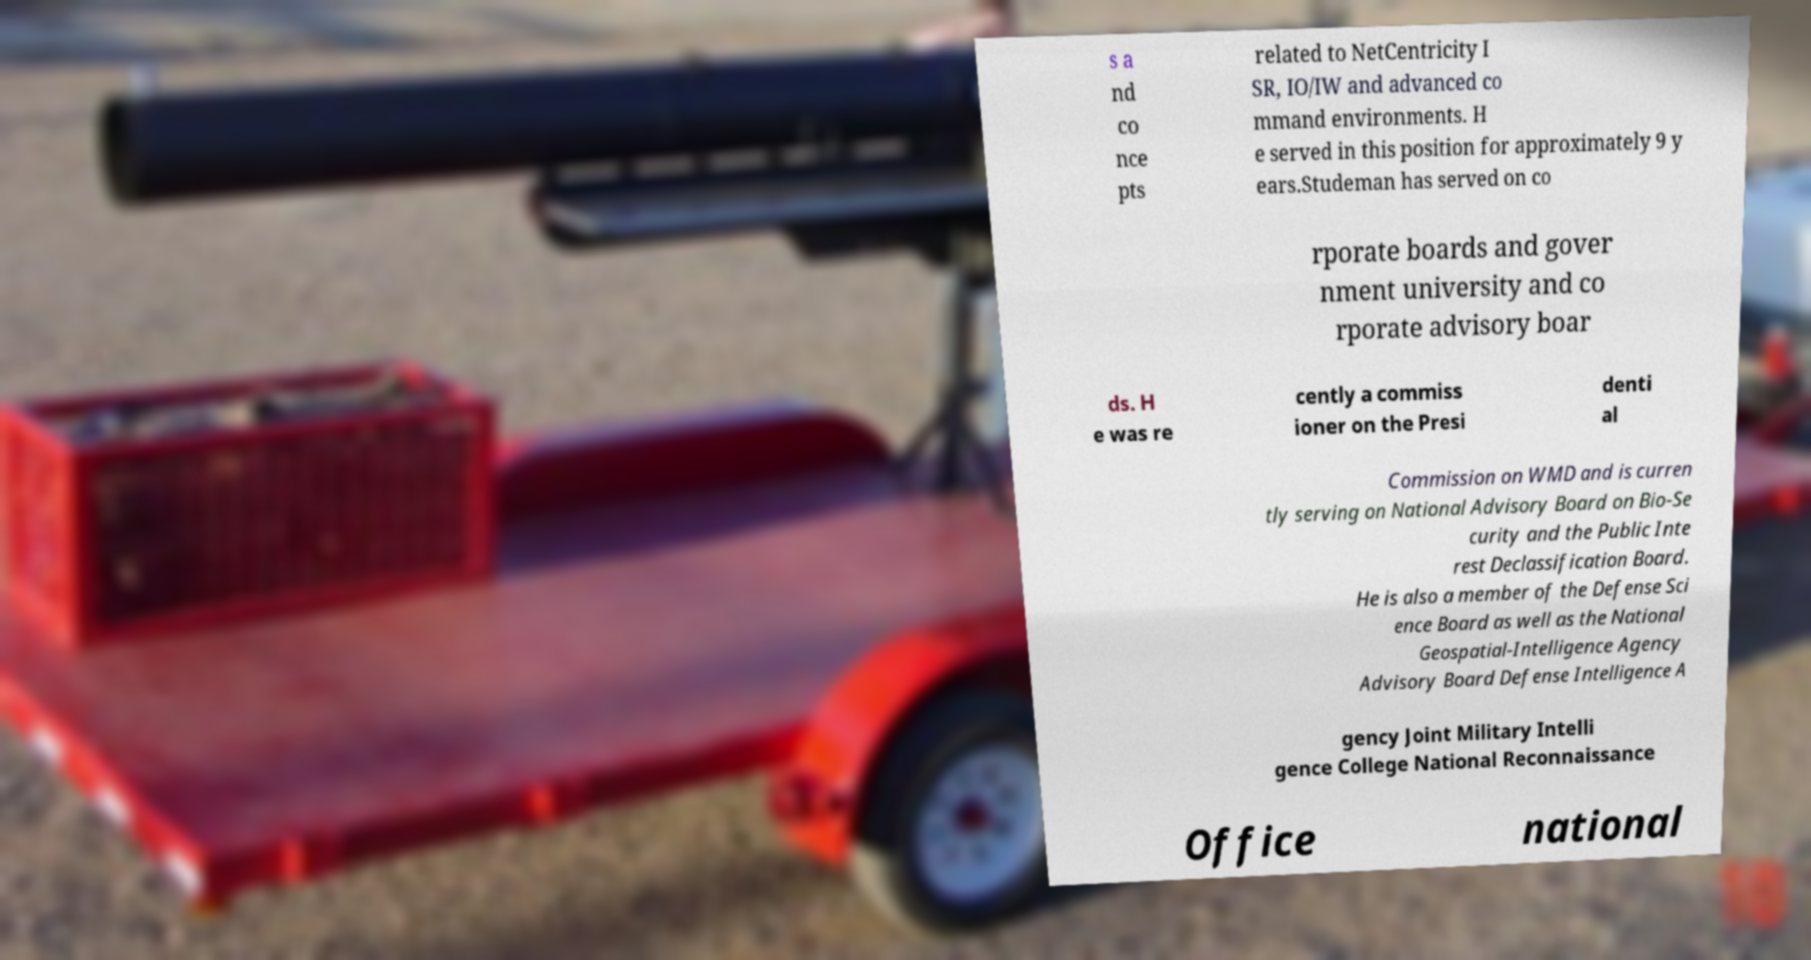There's text embedded in this image that I need extracted. Can you transcribe it verbatim? s a nd co nce pts related to NetCentricity I SR, IO/IW and advanced co mmand environments. H e served in this position for approximately 9 y ears.Studeman has served on co rporate boards and gover nment university and co rporate advisory boar ds. H e was re cently a commiss ioner on the Presi denti al Commission on WMD and is curren tly serving on National Advisory Board on Bio-Se curity and the Public Inte rest Declassification Board. He is also a member of the Defense Sci ence Board as well as the National Geospatial-Intelligence Agency Advisory Board Defense Intelligence A gency Joint Military Intelli gence College National Reconnaissance Office national 